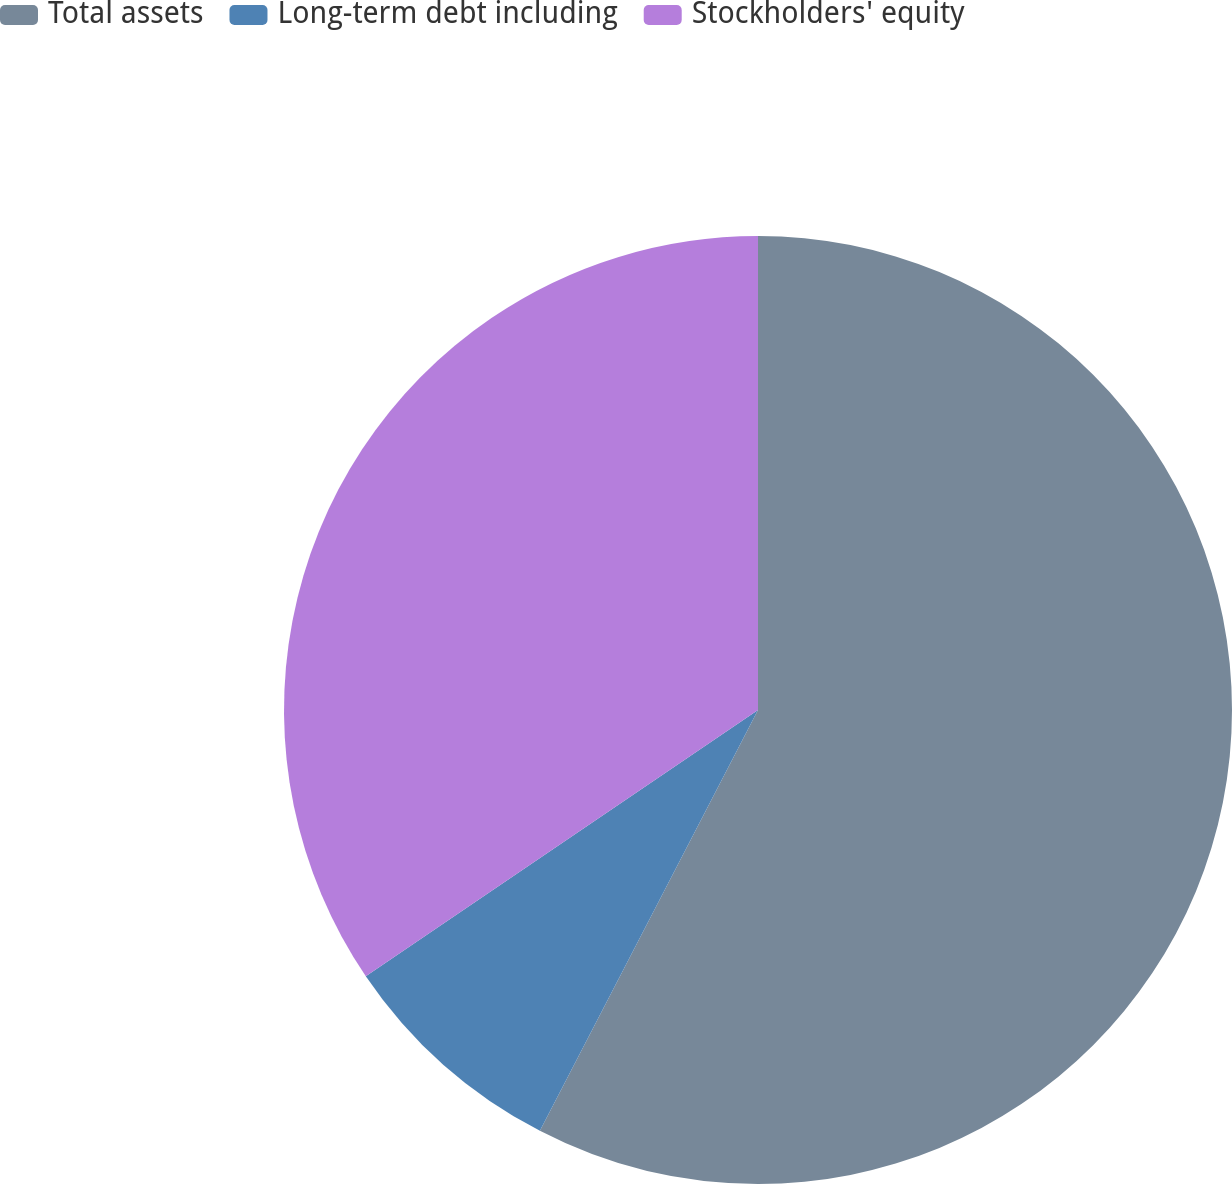Convert chart to OTSL. <chart><loc_0><loc_0><loc_500><loc_500><pie_chart><fcel>Total assets<fcel>Long-term debt including<fcel>Stockholders' equity<nl><fcel>57.61%<fcel>7.9%<fcel>34.49%<nl></chart> 